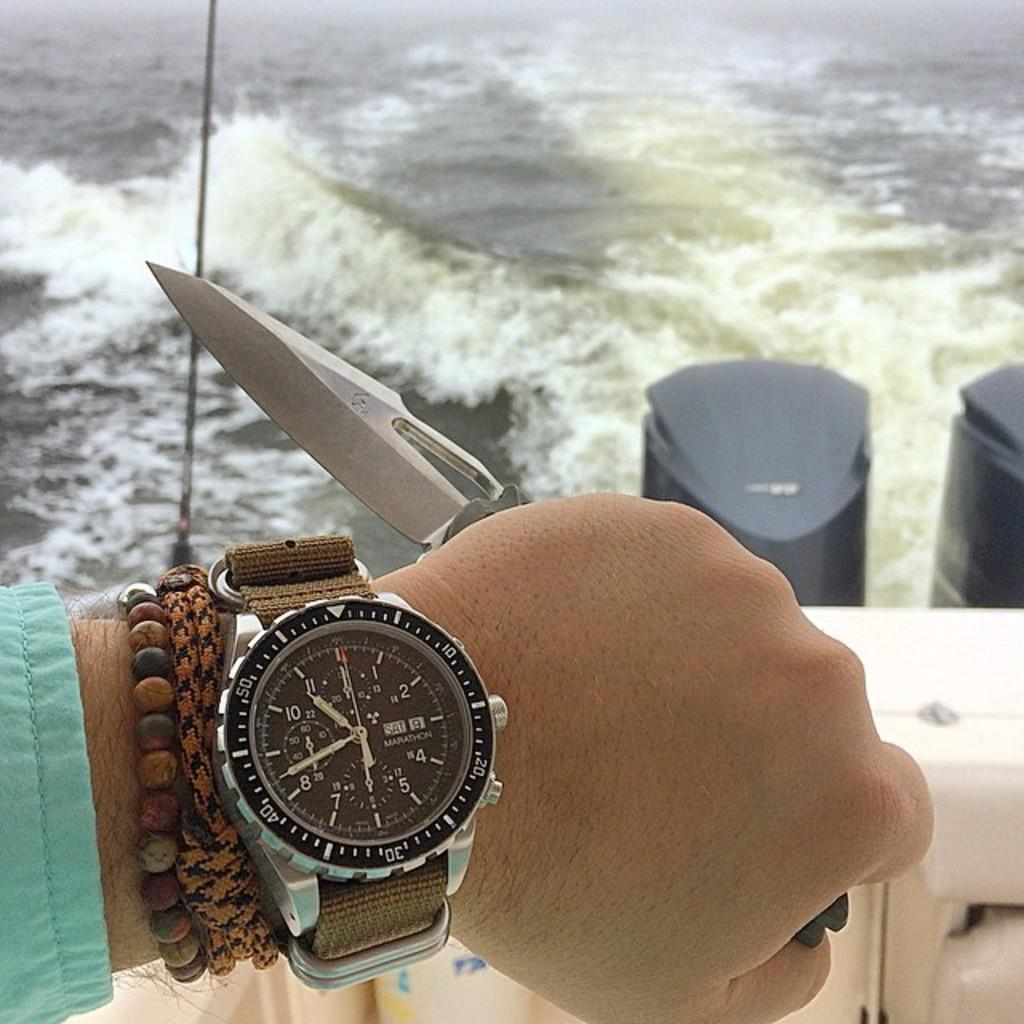<image>
Give a short and clear explanation of the subsequent image. Someone is on a boat, and their watch says that today is Saturday the ninth. 